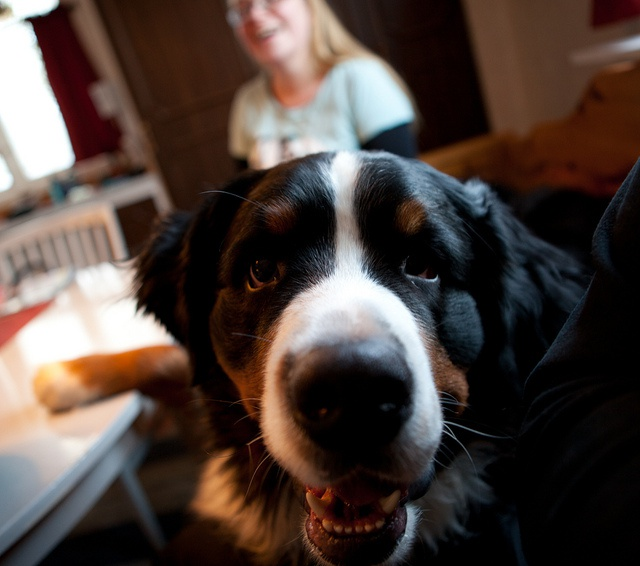Describe the objects in this image and their specific colors. I can see dog in lightgray, black, maroon, and gray tones, people in lightgray, black, navy, maroon, and darkblue tones, dining table in lightgray, white, darkgray, gray, and tan tones, people in lightgray, darkgray, tan, and gray tones, and couch in black, maroon, and lightgray tones in this image. 